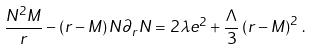Convert formula to latex. <formula><loc_0><loc_0><loc_500><loc_500>\frac { N ^ { 2 } M } { r } - \left ( r - M \right ) N \partial _ { r } N = 2 \lambda e ^ { 2 } + \frac { \Lambda } { 3 } \left ( r - M \right ) ^ { 2 } \, .</formula> 